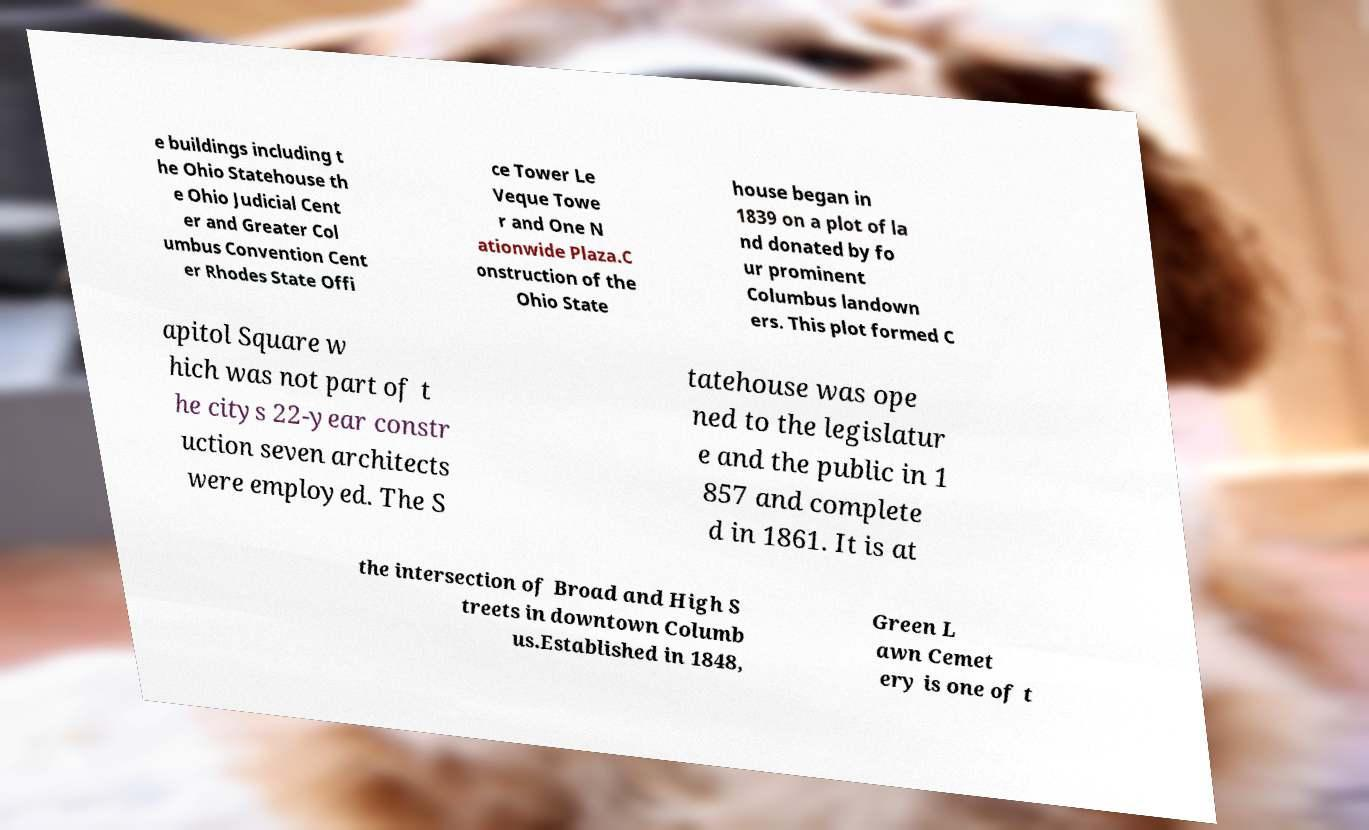For documentation purposes, I need the text within this image transcribed. Could you provide that? e buildings including t he Ohio Statehouse th e Ohio Judicial Cent er and Greater Col umbus Convention Cent er Rhodes State Offi ce Tower Le Veque Towe r and One N ationwide Plaza.C onstruction of the Ohio State house began in 1839 on a plot of la nd donated by fo ur prominent Columbus landown ers. This plot formed C apitol Square w hich was not part of t he citys 22-year constr uction seven architects were employed. The S tatehouse was ope ned to the legislatur e and the public in 1 857 and complete d in 1861. It is at the intersection of Broad and High S treets in downtown Columb us.Established in 1848, Green L awn Cemet ery is one of t 